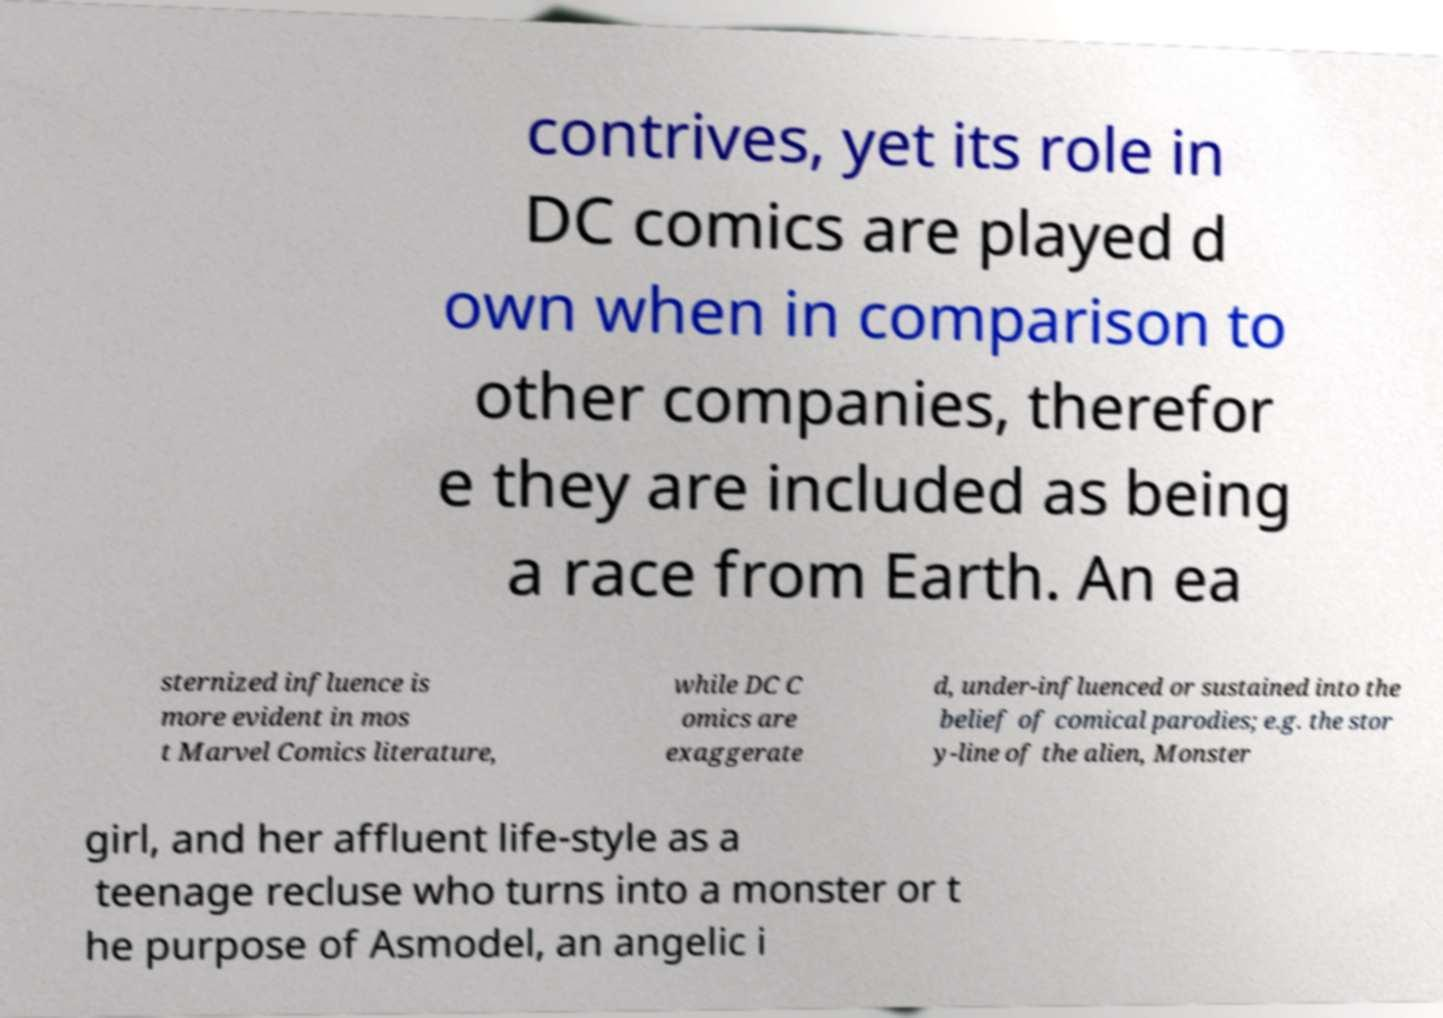Can you read and provide the text displayed in the image?This photo seems to have some interesting text. Can you extract and type it out for me? contrives, yet its role in DC comics are played d own when in comparison to other companies, therefor e they are included as being a race from Earth. An ea sternized influence is more evident in mos t Marvel Comics literature, while DC C omics are exaggerate d, under-influenced or sustained into the belief of comical parodies; e.g. the stor y-line of the alien, Monster girl, and her affluent life-style as a teenage recluse who turns into a monster or t he purpose of Asmodel, an angelic i 